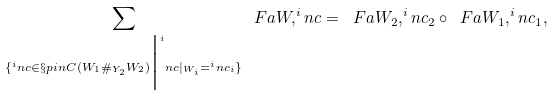Convert formula to latex. <formula><loc_0><loc_0><loc_500><loc_500>\sum _ { \{ ^ { i } n c \in \S p i n C ( W _ { 1 } \# _ { Y _ { 2 } } W _ { 2 } ) \Big | ^ { i } n c | _ { W _ { i } } = ^ { i } n c _ { i } \} } \ F a { W , ^ { i } n c } = \ F a { W _ { 2 } , ^ { i } n c _ { 2 } } \circ \ F a { W _ { 1 } , ^ { i } n c _ { 1 } } ,</formula> 